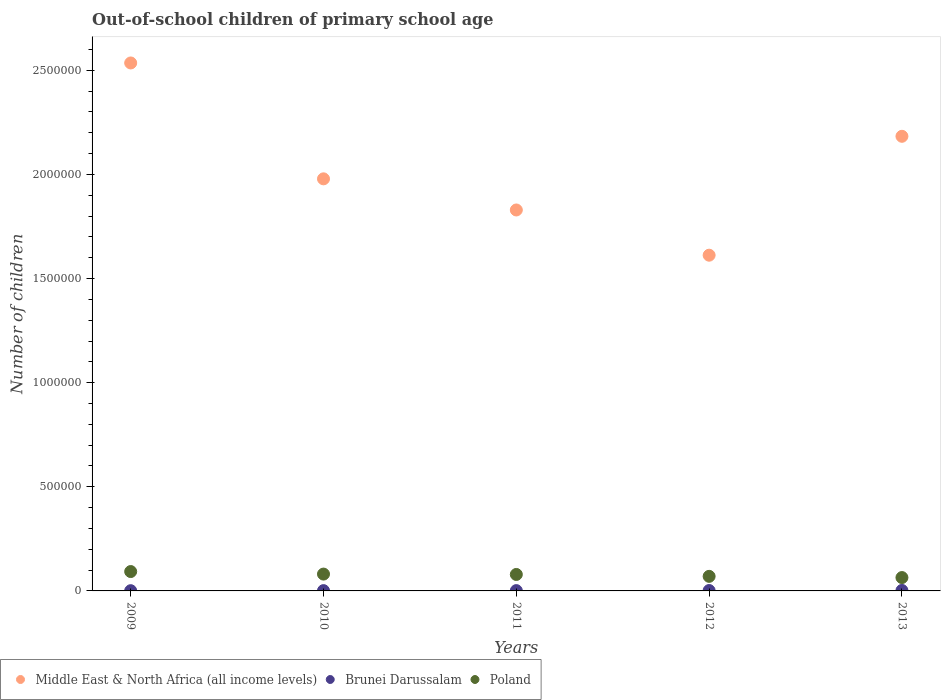How many different coloured dotlines are there?
Your answer should be compact. 3. Is the number of dotlines equal to the number of legend labels?
Provide a short and direct response. Yes. What is the number of out-of-school children in Middle East & North Africa (all income levels) in 2010?
Keep it short and to the point. 1.98e+06. Across all years, what is the maximum number of out-of-school children in Poland?
Provide a short and direct response. 9.30e+04. Across all years, what is the minimum number of out-of-school children in Brunei Darussalam?
Your answer should be compact. 1092. In which year was the number of out-of-school children in Middle East & North Africa (all income levels) minimum?
Make the answer very short. 2012. What is the total number of out-of-school children in Middle East & North Africa (all income levels) in the graph?
Provide a short and direct response. 1.01e+07. What is the difference between the number of out-of-school children in Brunei Darussalam in 2011 and that in 2012?
Keep it short and to the point. -466. What is the difference between the number of out-of-school children in Poland in 2011 and the number of out-of-school children in Middle East & North Africa (all income levels) in 2010?
Ensure brevity in your answer.  -1.90e+06. What is the average number of out-of-school children in Middle East & North Africa (all income levels) per year?
Provide a succinct answer. 2.03e+06. In the year 2010, what is the difference between the number of out-of-school children in Poland and number of out-of-school children in Middle East & North Africa (all income levels)?
Your answer should be very brief. -1.90e+06. What is the ratio of the number of out-of-school children in Middle East & North Africa (all income levels) in 2011 to that in 2012?
Your response must be concise. 1.13. What is the difference between the highest and the second highest number of out-of-school children in Middle East & North Africa (all income levels)?
Your response must be concise. 3.52e+05. What is the difference between the highest and the lowest number of out-of-school children in Poland?
Make the answer very short. 2.88e+04. Is it the case that in every year, the sum of the number of out-of-school children in Middle East & North Africa (all income levels) and number of out-of-school children in Brunei Darussalam  is greater than the number of out-of-school children in Poland?
Offer a terse response. Yes. Does the number of out-of-school children in Brunei Darussalam monotonically increase over the years?
Offer a very short reply. Yes. Is the number of out-of-school children in Middle East & North Africa (all income levels) strictly less than the number of out-of-school children in Brunei Darussalam over the years?
Your answer should be compact. No. What is the difference between two consecutive major ticks on the Y-axis?
Keep it short and to the point. 5.00e+05. Does the graph contain any zero values?
Ensure brevity in your answer.  No. Where does the legend appear in the graph?
Your response must be concise. Bottom left. What is the title of the graph?
Keep it short and to the point. Out-of-school children of primary school age. Does "Bosnia and Herzegovina" appear as one of the legend labels in the graph?
Offer a very short reply. No. What is the label or title of the X-axis?
Ensure brevity in your answer.  Years. What is the label or title of the Y-axis?
Offer a terse response. Number of children. What is the Number of children in Middle East & North Africa (all income levels) in 2009?
Provide a short and direct response. 2.54e+06. What is the Number of children in Brunei Darussalam in 2009?
Provide a succinct answer. 1092. What is the Number of children of Poland in 2009?
Your answer should be very brief. 9.30e+04. What is the Number of children in Middle East & North Africa (all income levels) in 2010?
Keep it short and to the point. 1.98e+06. What is the Number of children in Brunei Darussalam in 2010?
Offer a terse response. 1385. What is the Number of children in Poland in 2010?
Ensure brevity in your answer.  8.09e+04. What is the Number of children of Middle East & North Africa (all income levels) in 2011?
Offer a very short reply. 1.83e+06. What is the Number of children in Brunei Darussalam in 2011?
Offer a very short reply. 1478. What is the Number of children of Poland in 2011?
Keep it short and to the point. 7.91e+04. What is the Number of children of Middle East & North Africa (all income levels) in 2012?
Give a very brief answer. 1.61e+06. What is the Number of children in Brunei Darussalam in 2012?
Your response must be concise. 1944. What is the Number of children of Poland in 2012?
Provide a short and direct response. 6.99e+04. What is the Number of children of Middle East & North Africa (all income levels) in 2013?
Your answer should be very brief. 2.18e+06. What is the Number of children in Brunei Darussalam in 2013?
Your response must be concise. 2275. What is the Number of children in Poland in 2013?
Provide a short and direct response. 6.41e+04. Across all years, what is the maximum Number of children in Middle East & North Africa (all income levels)?
Offer a terse response. 2.54e+06. Across all years, what is the maximum Number of children of Brunei Darussalam?
Your answer should be very brief. 2275. Across all years, what is the maximum Number of children in Poland?
Ensure brevity in your answer.  9.30e+04. Across all years, what is the minimum Number of children of Middle East & North Africa (all income levels)?
Provide a succinct answer. 1.61e+06. Across all years, what is the minimum Number of children in Brunei Darussalam?
Give a very brief answer. 1092. Across all years, what is the minimum Number of children in Poland?
Your answer should be very brief. 6.41e+04. What is the total Number of children in Middle East & North Africa (all income levels) in the graph?
Ensure brevity in your answer.  1.01e+07. What is the total Number of children in Brunei Darussalam in the graph?
Your response must be concise. 8174. What is the total Number of children in Poland in the graph?
Keep it short and to the point. 3.87e+05. What is the difference between the Number of children of Middle East & North Africa (all income levels) in 2009 and that in 2010?
Your answer should be very brief. 5.56e+05. What is the difference between the Number of children of Brunei Darussalam in 2009 and that in 2010?
Offer a very short reply. -293. What is the difference between the Number of children in Poland in 2009 and that in 2010?
Your response must be concise. 1.21e+04. What is the difference between the Number of children in Middle East & North Africa (all income levels) in 2009 and that in 2011?
Offer a terse response. 7.06e+05. What is the difference between the Number of children of Brunei Darussalam in 2009 and that in 2011?
Offer a very short reply. -386. What is the difference between the Number of children in Poland in 2009 and that in 2011?
Your answer should be compact. 1.39e+04. What is the difference between the Number of children of Middle East & North Africa (all income levels) in 2009 and that in 2012?
Offer a very short reply. 9.23e+05. What is the difference between the Number of children in Brunei Darussalam in 2009 and that in 2012?
Offer a terse response. -852. What is the difference between the Number of children of Poland in 2009 and that in 2012?
Offer a terse response. 2.30e+04. What is the difference between the Number of children of Middle East & North Africa (all income levels) in 2009 and that in 2013?
Offer a terse response. 3.52e+05. What is the difference between the Number of children of Brunei Darussalam in 2009 and that in 2013?
Give a very brief answer. -1183. What is the difference between the Number of children in Poland in 2009 and that in 2013?
Provide a short and direct response. 2.88e+04. What is the difference between the Number of children of Middle East & North Africa (all income levels) in 2010 and that in 2011?
Offer a very short reply. 1.50e+05. What is the difference between the Number of children of Brunei Darussalam in 2010 and that in 2011?
Give a very brief answer. -93. What is the difference between the Number of children of Poland in 2010 and that in 2011?
Keep it short and to the point. 1799. What is the difference between the Number of children in Middle East & North Africa (all income levels) in 2010 and that in 2012?
Give a very brief answer. 3.67e+05. What is the difference between the Number of children of Brunei Darussalam in 2010 and that in 2012?
Your response must be concise. -559. What is the difference between the Number of children in Poland in 2010 and that in 2012?
Your response must be concise. 1.09e+04. What is the difference between the Number of children of Middle East & North Africa (all income levels) in 2010 and that in 2013?
Ensure brevity in your answer.  -2.04e+05. What is the difference between the Number of children of Brunei Darussalam in 2010 and that in 2013?
Your response must be concise. -890. What is the difference between the Number of children of Poland in 2010 and that in 2013?
Your response must be concise. 1.67e+04. What is the difference between the Number of children in Middle East & North Africa (all income levels) in 2011 and that in 2012?
Provide a short and direct response. 2.17e+05. What is the difference between the Number of children in Brunei Darussalam in 2011 and that in 2012?
Ensure brevity in your answer.  -466. What is the difference between the Number of children in Poland in 2011 and that in 2012?
Provide a succinct answer. 9118. What is the difference between the Number of children of Middle East & North Africa (all income levels) in 2011 and that in 2013?
Your answer should be very brief. -3.54e+05. What is the difference between the Number of children of Brunei Darussalam in 2011 and that in 2013?
Keep it short and to the point. -797. What is the difference between the Number of children in Poland in 2011 and that in 2013?
Keep it short and to the point. 1.49e+04. What is the difference between the Number of children in Middle East & North Africa (all income levels) in 2012 and that in 2013?
Your answer should be compact. -5.71e+05. What is the difference between the Number of children of Brunei Darussalam in 2012 and that in 2013?
Your answer should be very brief. -331. What is the difference between the Number of children of Poland in 2012 and that in 2013?
Keep it short and to the point. 5798. What is the difference between the Number of children of Middle East & North Africa (all income levels) in 2009 and the Number of children of Brunei Darussalam in 2010?
Your response must be concise. 2.53e+06. What is the difference between the Number of children in Middle East & North Africa (all income levels) in 2009 and the Number of children in Poland in 2010?
Offer a terse response. 2.45e+06. What is the difference between the Number of children of Brunei Darussalam in 2009 and the Number of children of Poland in 2010?
Give a very brief answer. -7.98e+04. What is the difference between the Number of children of Middle East & North Africa (all income levels) in 2009 and the Number of children of Brunei Darussalam in 2011?
Provide a short and direct response. 2.53e+06. What is the difference between the Number of children of Middle East & North Africa (all income levels) in 2009 and the Number of children of Poland in 2011?
Provide a short and direct response. 2.46e+06. What is the difference between the Number of children of Brunei Darussalam in 2009 and the Number of children of Poland in 2011?
Offer a very short reply. -7.80e+04. What is the difference between the Number of children of Middle East & North Africa (all income levels) in 2009 and the Number of children of Brunei Darussalam in 2012?
Offer a very short reply. 2.53e+06. What is the difference between the Number of children of Middle East & North Africa (all income levels) in 2009 and the Number of children of Poland in 2012?
Keep it short and to the point. 2.47e+06. What is the difference between the Number of children of Brunei Darussalam in 2009 and the Number of children of Poland in 2012?
Keep it short and to the point. -6.89e+04. What is the difference between the Number of children in Middle East & North Africa (all income levels) in 2009 and the Number of children in Brunei Darussalam in 2013?
Make the answer very short. 2.53e+06. What is the difference between the Number of children in Middle East & North Africa (all income levels) in 2009 and the Number of children in Poland in 2013?
Your answer should be very brief. 2.47e+06. What is the difference between the Number of children in Brunei Darussalam in 2009 and the Number of children in Poland in 2013?
Your answer should be compact. -6.31e+04. What is the difference between the Number of children of Middle East & North Africa (all income levels) in 2010 and the Number of children of Brunei Darussalam in 2011?
Your answer should be compact. 1.98e+06. What is the difference between the Number of children in Middle East & North Africa (all income levels) in 2010 and the Number of children in Poland in 2011?
Your answer should be compact. 1.90e+06. What is the difference between the Number of children of Brunei Darussalam in 2010 and the Number of children of Poland in 2011?
Your response must be concise. -7.77e+04. What is the difference between the Number of children in Middle East & North Africa (all income levels) in 2010 and the Number of children in Brunei Darussalam in 2012?
Ensure brevity in your answer.  1.98e+06. What is the difference between the Number of children in Middle East & North Africa (all income levels) in 2010 and the Number of children in Poland in 2012?
Give a very brief answer. 1.91e+06. What is the difference between the Number of children in Brunei Darussalam in 2010 and the Number of children in Poland in 2012?
Provide a succinct answer. -6.86e+04. What is the difference between the Number of children in Middle East & North Africa (all income levels) in 2010 and the Number of children in Brunei Darussalam in 2013?
Offer a terse response. 1.98e+06. What is the difference between the Number of children of Middle East & North Africa (all income levels) in 2010 and the Number of children of Poland in 2013?
Make the answer very short. 1.91e+06. What is the difference between the Number of children in Brunei Darussalam in 2010 and the Number of children in Poland in 2013?
Offer a very short reply. -6.28e+04. What is the difference between the Number of children of Middle East & North Africa (all income levels) in 2011 and the Number of children of Brunei Darussalam in 2012?
Offer a very short reply. 1.83e+06. What is the difference between the Number of children of Middle East & North Africa (all income levels) in 2011 and the Number of children of Poland in 2012?
Your answer should be very brief. 1.76e+06. What is the difference between the Number of children in Brunei Darussalam in 2011 and the Number of children in Poland in 2012?
Offer a very short reply. -6.85e+04. What is the difference between the Number of children of Middle East & North Africa (all income levels) in 2011 and the Number of children of Brunei Darussalam in 2013?
Make the answer very short. 1.83e+06. What is the difference between the Number of children of Middle East & North Africa (all income levels) in 2011 and the Number of children of Poland in 2013?
Your answer should be very brief. 1.77e+06. What is the difference between the Number of children of Brunei Darussalam in 2011 and the Number of children of Poland in 2013?
Your response must be concise. -6.27e+04. What is the difference between the Number of children in Middle East & North Africa (all income levels) in 2012 and the Number of children in Brunei Darussalam in 2013?
Provide a short and direct response. 1.61e+06. What is the difference between the Number of children of Middle East & North Africa (all income levels) in 2012 and the Number of children of Poland in 2013?
Ensure brevity in your answer.  1.55e+06. What is the difference between the Number of children in Brunei Darussalam in 2012 and the Number of children in Poland in 2013?
Offer a terse response. -6.22e+04. What is the average Number of children of Middle East & North Africa (all income levels) per year?
Provide a succinct answer. 2.03e+06. What is the average Number of children of Brunei Darussalam per year?
Keep it short and to the point. 1634.8. What is the average Number of children of Poland per year?
Offer a terse response. 7.74e+04. In the year 2009, what is the difference between the Number of children of Middle East & North Africa (all income levels) and Number of children of Brunei Darussalam?
Give a very brief answer. 2.53e+06. In the year 2009, what is the difference between the Number of children in Middle East & North Africa (all income levels) and Number of children in Poland?
Offer a terse response. 2.44e+06. In the year 2009, what is the difference between the Number of children of Brunei Darussalam and Number of children of Poland?
Ensure brevity in your answer.  -9.19e+04. In the year 2010, what is the difference between the Number of children of Middle East & North Africa (all income levels) and Number of children of Brunei Darussalam?
Provide a short and direct response. 1.98e+06. In the year 2010, what is the difference between the Number of children of Middle East & North Africa (all income levels) and Number of children of Poland?
Your response must be concise. 1.90e+06. In the year 2010, what is the difference between the Number of children of Brunei Darussalam and Number of children of Poland?
Ensure brevity in your answer.  -7.95e+04. In the year 2011, what is the difference between the Number of children in Middle East & North Africa (all income levels) and Number of children in Brunei Darussalam?
Your answer should be very brief. 1.83e+06. In the year 2011, what is the difference between the Number of children of Middle East & North Africa (all income levels) and Number of children of Poland?
Your answer should be compact. 1.75e+06. In the year 2011, what is the difference between the Number of children of Brunei Darussalam and Number of children of Poland?
Keep it short and to the point. -7.76e+04. In the year 2012, what is the difference between the Number of children in Middle East & North Africa (all income levels) and Number of children in Brunei Darussalam?
Provide a succinct answer. 1.61e+06. In the year 2012, what is the difference between the Number of children of Middle East & North Africa (all income levels) and Number of children of Poland?
Your answer should be compact. 1.54e+06. In the year 2012, what is the difference between the Number of children of Brunei Darussalam and Number of children of Poland?
Offer a very short reply. -6.80e+04. In the year 2013, what is the difference between the Number of children of Middle East & North Africa (all income levels) and Number of children of Brunei Darussalam?
Give a very brief answer. 2.18e+06. In the year 2013, what is the difference between the Number of children in Middle East & North Africa (all income levels) and Number of children in Poland?
Offer a very short reply. 2.12e+06. In the year 2013, what is the difference between the Number of children of Brunei Darussalam and Number of children of Poland?
Give a very brief answer. -6.19e+04. What is the ratio of the Number of children in Middle East & North Africa (all income levels) in 2009 to that in 2010?
Your answer should be compact. 1.28. What is the ratio of the Number of children of Brunei Darussalam in 2009 to that in 2010?
Keep it short and to the point. 0.79. What is the ratio of the Number of children of Poland in 2009 to that in 2010?
Ensure brevity in your answer.  1.15. What is the ratio of the Number of children of Middle East & North Africa (all income levels) in 2009 to that in 2011?
Give a very brief answer. 1.39. What is the ratio of the Number of children of Brunei Darussalam in 2009 to that in 2011?
Your answer should be compact. 0.74. What is the ratio of the Number of children of Poland in 2009 to that in 2011?
Make the answer very short. 1.18. What is the ratio of the Number of children in Middle East & North Africa (all income levels) in 2009 to that in 2012?
Ensure brevity in your answer.  1.57. What is the ratio of the Number of children in Brunei Darussalam in 2009 to that in 2012?
Keep it short and to the point. 0.56. What is the ratio of the Number of children in Poland in 2009 to that in 2012?
Your response must be concise. 1.33. What is the ratio of the Number of children in Middle East & North Africa (all income levels) in 2009 to that in 2013?
Keep it short and to the point. 1.16. What is the ratio of the Number of children in Brunei Darussalam in 2009 to that in 2013?
Your answer should be compact. 0.48. What is the ratio of the Number of children of Poland in 2009 to that in 2013?
Provide a short and direct response. 1.45. What is the ratio of the Number of children in Middle East & North Africa (all income levels) in 2010 to that in 2011?
Your response must be concise. 1.08. What is the ratio of the Number of children in Brunei Darussalam in 2010 to that in 2011?
Keep it short and to the point. 0.94. What is the ratio of the Number of children in Poland in 2010 to that in 2011?
Offer a very short reply. 1.02. What is the ratio of the Number of children in Middle East & North Africa (all income levels) in 2010 to that in 2012?
Provide a succinct answer. 1.23. What is the ratio of the Number of children in Brunei Darussalam in 2010 to that in 2012?
Your response must be concise. 0.71. What is the ratio of the Number of children of Poland in 2010 to that in 2012?
Your response must be concise. 1.16. What is the ratio of the Number of children in Middle East & North Africa (all income levels) in 2010 to that in 2013?
Keep it short and to the point. 0.91. What is the ratio of the Number of children of Brunei Darussalam in 2010 to that in 2013?
Your response must be concise. 0.61. What is the ratio of the Number of children of Poland in 2010 to that in 2013?
Provide a short and direct response. 1.26. What is the ratio of the Number of children in Middle East & North Africa (all income levels) in 2011 to that in 2012?
Give a very brief answer. 1.13. What is the ratio of the Number of children of Brunei Darussalam in 2011 to that in 2012?
Keep it short and to the point. 0.76. What is the ratio of the Number of children in Poland in 2011 to that in 2012?
Ensure brevity in your answer.  1.13. What is the ratio of the Number of children of Middle East & North Africa (all income levels) in 2011 to that in 2013?
Your answer should be very brief. 0.84. What is the ratio of the Number of children of Brunei Darussalam in 2011 to that in 2013?
Make the answer very short. 0.65. What is the ratio of the Number of children in Poland in 2011 to that in 2013?
Offer a very short reply. 1.23. What is the ratio of the Number of children of Middle East & North Africa (all income levels) in 2012 to that in 2013?
Give a very brief answer. 0.74. What is the ratio of the Number of children of Brunei Darussalam in 2012 to that in 2013?
Give a very brief answer. 0.85. What is the ratio of the Number of children of Poland in 2012 to that in 2013?
Ensure brevity in your answer.  1.09. What is the difference between the highest and the second highest Number of children in Middle East & North Africa (all income levels)?
Your response must be concise. 3.52e+05. What is the difference between the highest and the second highest Number of children in Brunei Darussalam?
Your answer should be very brief. 331. What is the difference between the highest and the second highest Number of children of Poland?
Your answer should be very brief. 1.21e+04. What is the difference between the highest and the lowest Number of children of Middle East & North Africa (all income levels)?
Keep it short and to the point. 9.23e+05. What is the difference between the highest and the lowest Number of children of Brunei Darussalam?
Make the answer very short. 1183. What is the difference between the highest and the lowest Number of children in Poland?
Offer a terse response. 2.88e+04. 